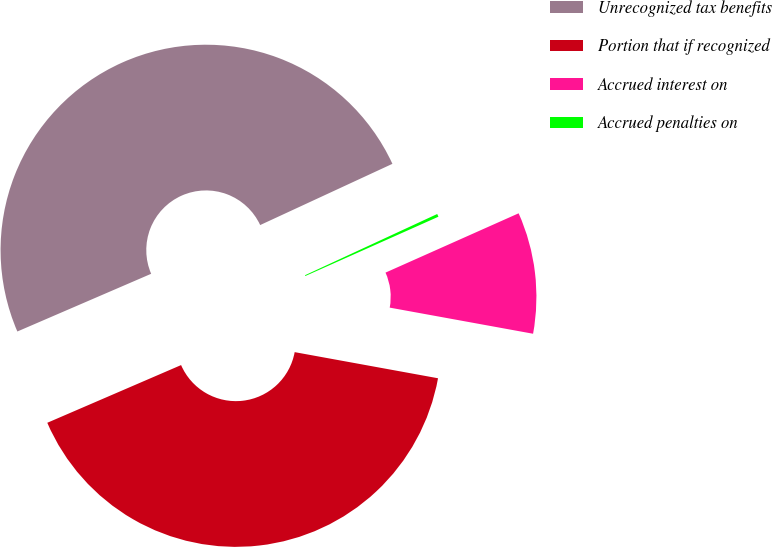<chart> <loc_0><loc_0><loc_500><loc_500><pie_chart><fcel>Unrecognized tax benefits<fcel>Portion that if recognized<fcel>Accrued interest on<fcel>Accrued penalties on<nl><fcel>49.58%<fcel>40.65%<fcel>9.54%<fcel>0.23%<nl></chart> 